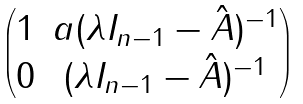Convert formula to latex. <formula><loc_0><loc_0><loc_500><loc_500>\begin{pmatrix} 1 & a ( \lambda I _ { n - 1 } - \hat { A } ) ^ { - 1 } \\ 0 & ( \lambda I _ { n - 1 } - \hat { A } ) ^ { - 1 } \end{pmatrix}</formula> 